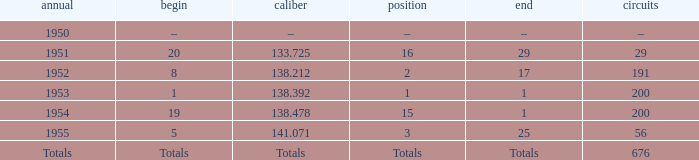How many laps was qualifier of 138.212? 191.0. 